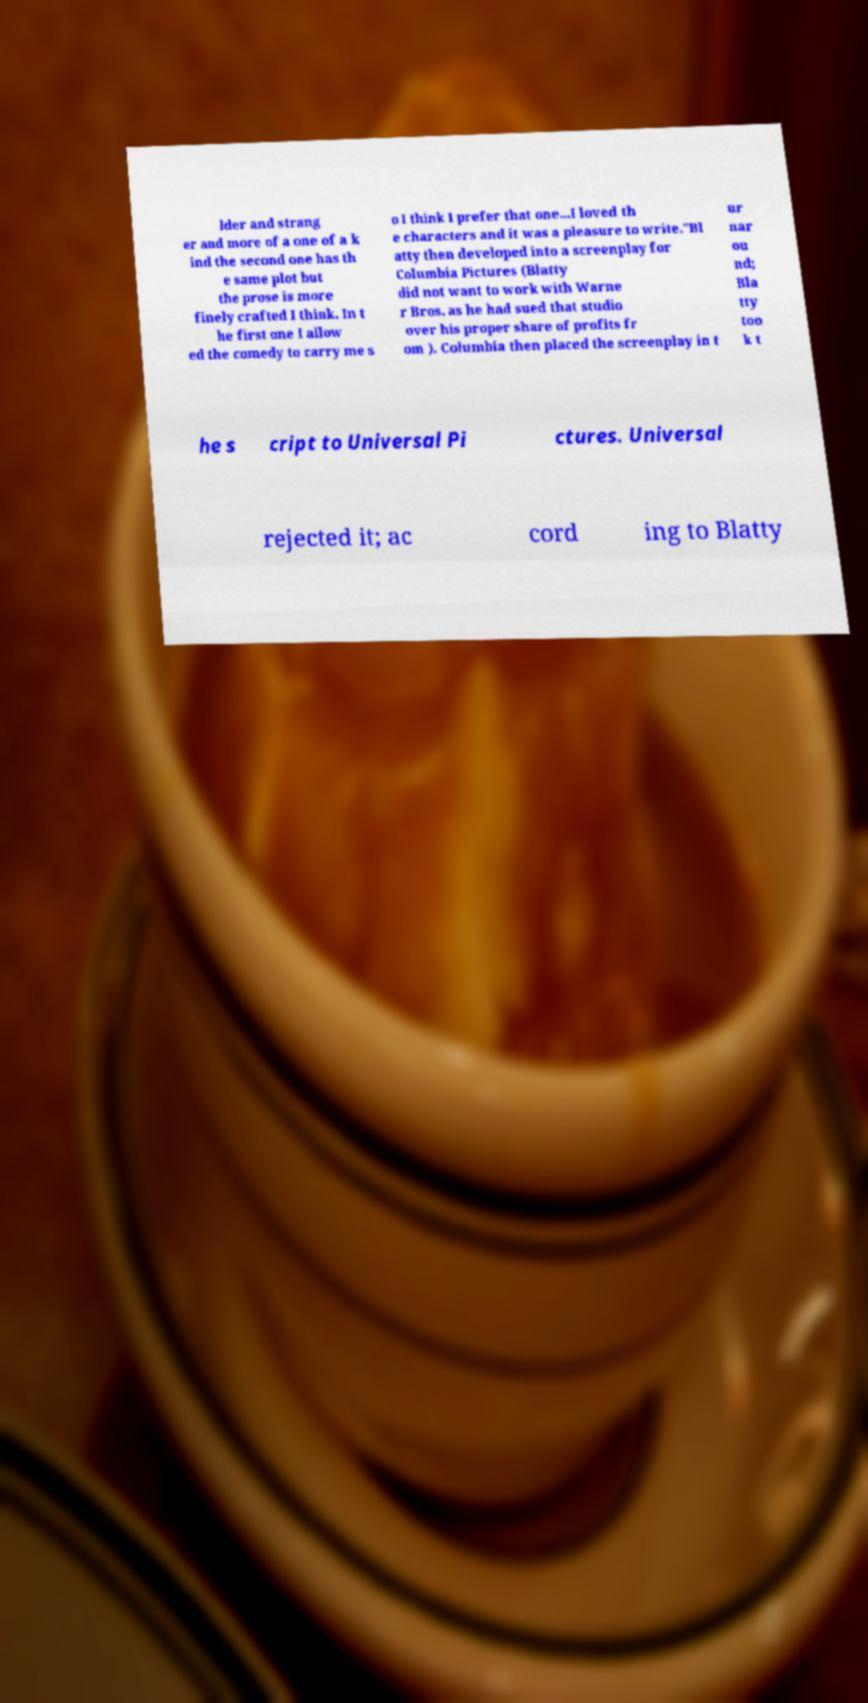What messages or text are displayed in this image? I need them in a readable, typed format. lder and strang er and more of a one of a k ind the second one has th e same plot but the prose is more finely crafted I think. In t he first one I allow ed the comedy to carry me s o I think I prefer that one...I loved th e characters and it was a pleasure to write."Bl atty then developed into a screenplay for Columbia Pictures (Blatty did not want to work with Warne r Bros. as he had sued that studio over his proper share of profits fr om ). Columbia then placed the screenplay in t ur nar ou nd; Bla tty too k t he s cript to Universal Pi ctures. Universal rejected it; ac cord ing to Blatty 